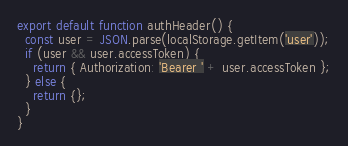<code> <loc_0><loc_0><loc_500><loc_500><_JavaScript_>export default function authHeader() {
  const user = JSON.parse(localStorage.getItem('user'));
  if (user && user.accessToken) {
    return { Authorization: 'Bearer ' + user.accessToken };
  } else {
    return {};
  }
}</code> 